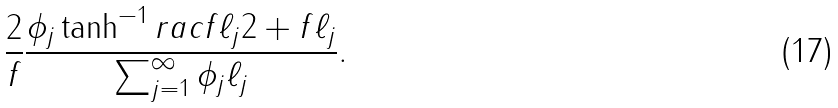Convert formula to latex. <formula><loc_0><loc_0><loc_500><loc_500>\frac { 2 } { f } \frac { \phi _ { j } \tanh ^ { - 1 } r a c { f \ell _ { j } } { 2 + f \ell _ { j } } } { \sum _ { j = 1 } ^ { \infty } \phi _ { j } \ell _ { j } } .</formula> 